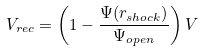<formula> <loc_0><loc_0><loc_500><loc_500>V _ { r e c } = \left ( 1 - \frac { \Psi ( r _ { s h o c k } ) } { \Psi _ { o p e n } } \right ) V</formula> 